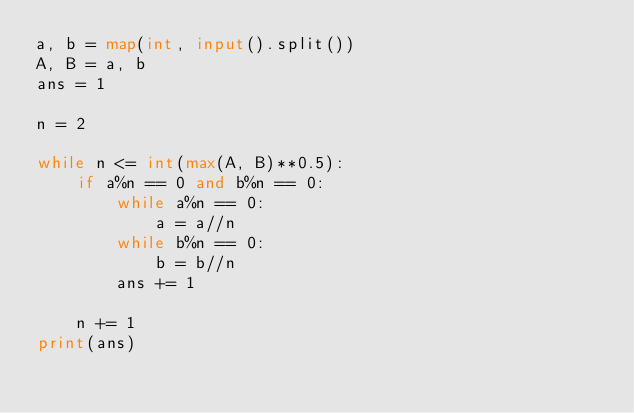Convert code to text. <code><loc_0><loc_0><loc_500><loc_500><_Python_>a, b = map(int, input().split())
A, B = a, b
ans = 1

n = 2

while n <= int(max(A, B)**0.5):
    if a%n == 0 and b%n == 0:
        while a%n == 0:
            a = a//n
        while b%n == 0:
            b = b//n
        ans += 1
    
    n += 1
print(ans)

</code> 